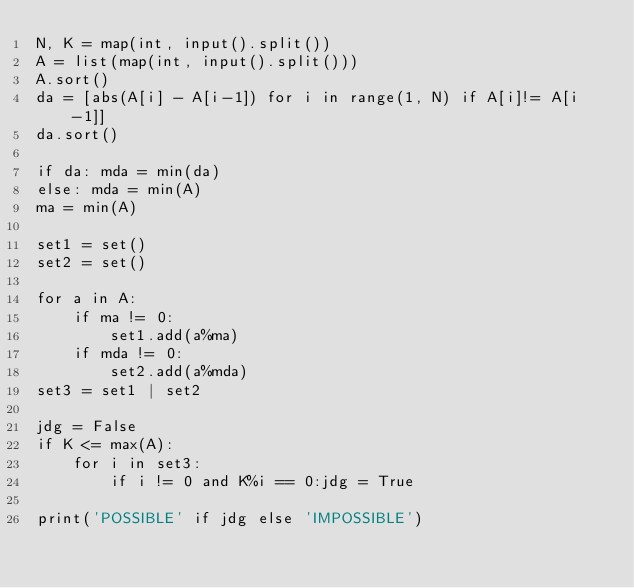Convert code to text. <code><loc_0><loc_0><loc_500><loc_500><_Python_>N, K = map(int, input().split())
A = list(map(int, input().split()))
A.sort()
da = [abs(A[i] - A[i-1]) for i in range(1, N) if A[i]!= A[i-1]]
da.sort()

if da: mda = min(da)
else: mda = min(A)
ma = min(A)

set1 = set()
set2 = set()

for a in A:
    if ma != 0:
        set1.add(a%ma)
    if mda != 0:
        set2.add(a%mda)
set3 = set1 | set2

jdg = False
if K <= max(A):
    for i in set3: 
        if i != 0 and K%i == 0:jdg = True

print('POSSIBLE' if jdg else 'IMPOSSIBLE')
</code> 